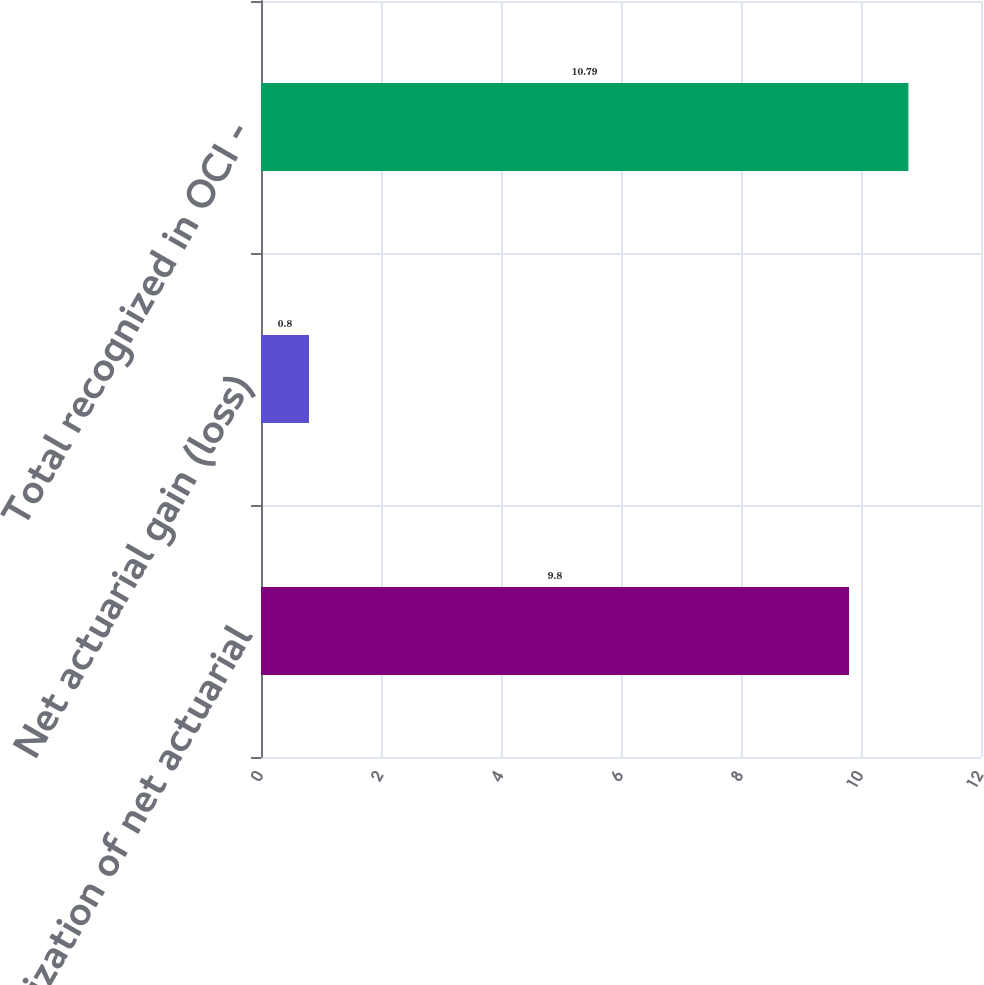Convert chart. <chart><loc_0><loc_0><loc_500><loc_500><bar_chart><fcel>Amortization of net actuarial<fcel>Net actuarial gain (loss)<fcel>Total recognized in OCI -<nl><fcel>9.8<fcel>0.8<fcel>10.79<nl></chart> 